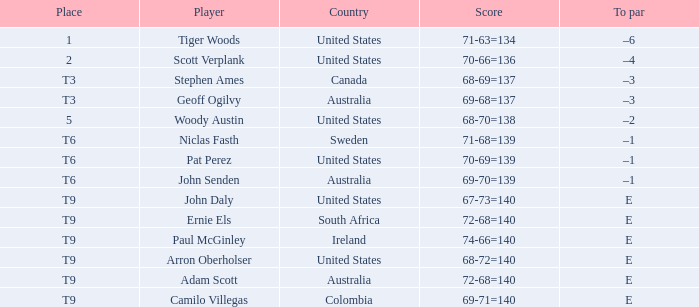What nation does adam scott originate from? Australia. 